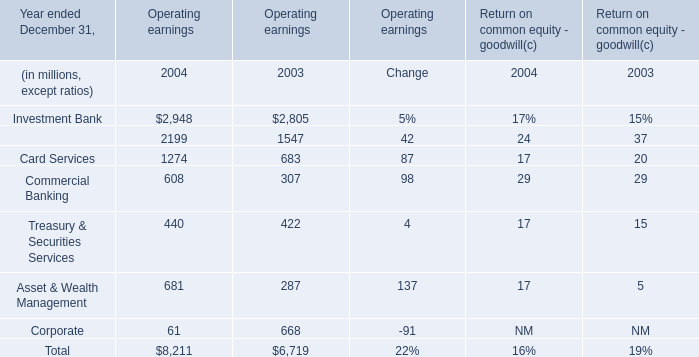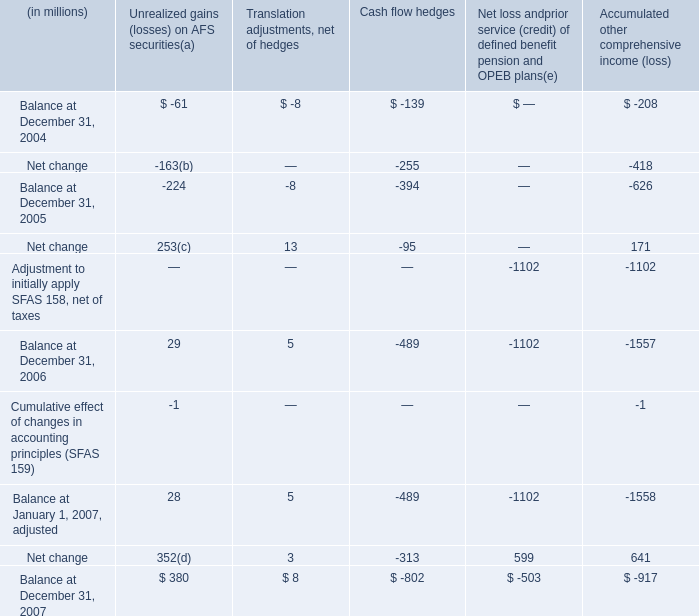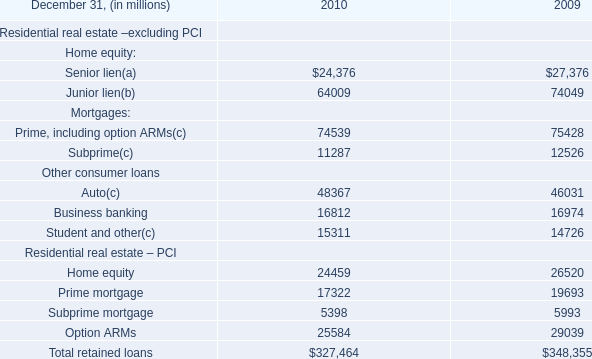What is the sum of Retail Financial Services of Operating earnings 2003, Student and other Other consumer loans of 2009, and Prime mortgage Residential real estate – PCI of 2009 ? 
Computations: ((1547.0 + 14726.0) + 19693.0)
Answer: 35966.0. 